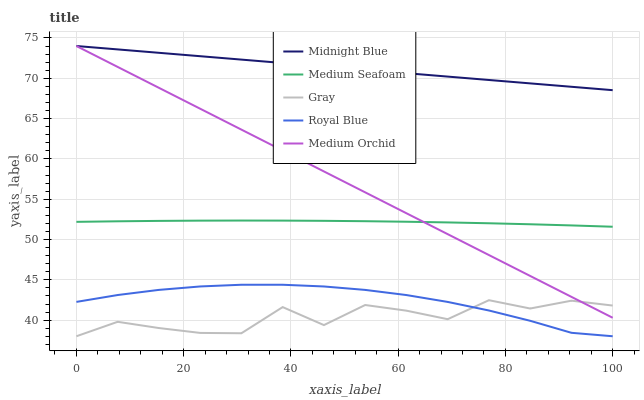Does Medium Orchid have the minimum area under the curve?
Answer yes or no. No. Does Medium Orchid have the maximum area under the curve?
Answer yes or no. No. Is Medium Orchid the smoothest?
Answer yes or no. No. Is Medium Orchid the roughest?
Answer yes or no. No. Does Medium Orchid have the lowest value?
Answer yes or no. No. Does Royal Blue have the highest value?
Answer yes or no. No. Is Royal Blue less than Midnight Blue?
Answer yes or no. Yes. Is Medium Seafoam greater than Royal Blue?
Answer yes or no. Yes. Does Royal Blue intersect Midnight Blue?
Answer yes or no. No. 